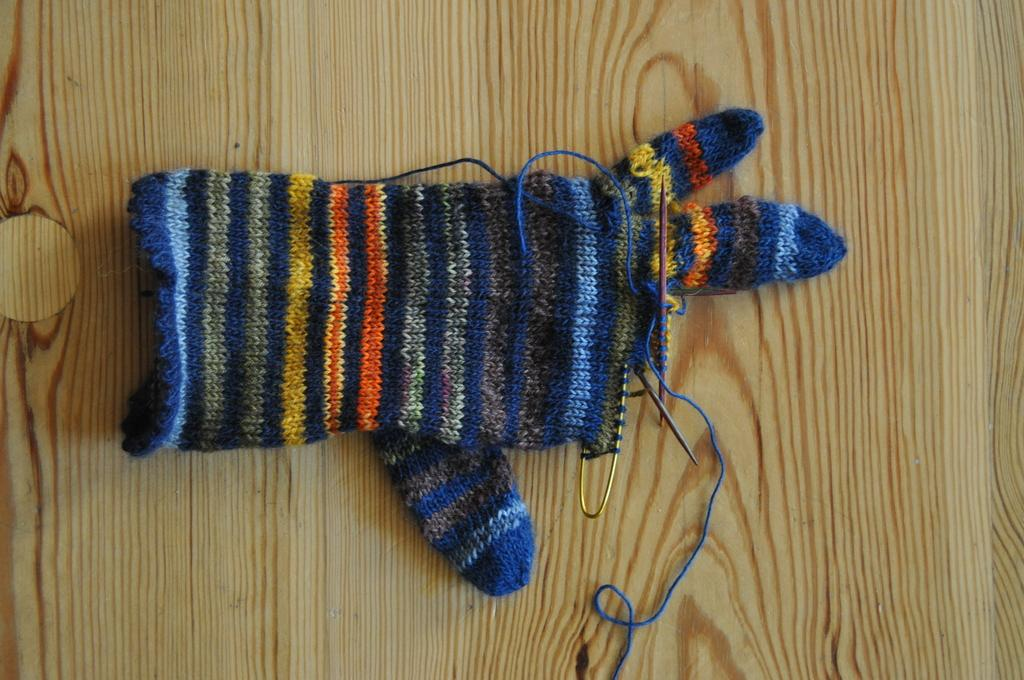What is the main object in the image? There is an unstitched woollen hand glove in the image. Where is the hand glove located? The hand glove is kept on a table. What can be seen on the hand glove? There are sewing pins on the hand glove. What type of fuel is being used to power the sewing machine in the image? There is no sewing machine present in the image, so it is not possible to determine what type of fuel might be used. 